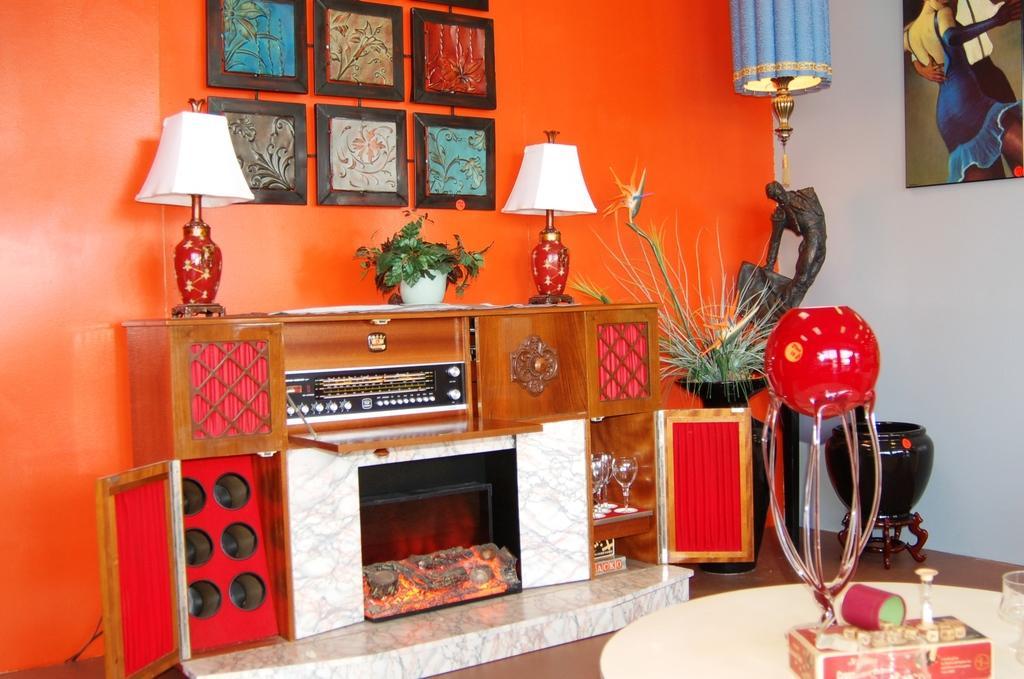In one or two sentences, can you explain what this image depicts? In this image in front there is a table. On top of it there is a glass and a few other objects. In the center of the image there is a fireplace. On top of it there are lamps, flower pot. There are glasses in the cupboard and there are a few other objects inside the cupboard. In the background of the image there are photo frames on the wall. On the right side of the image there is a flower pot. Beside the flower pot there is a lamp. Beside the lamp there is a pot. At the bottom of the image there is a floor. 